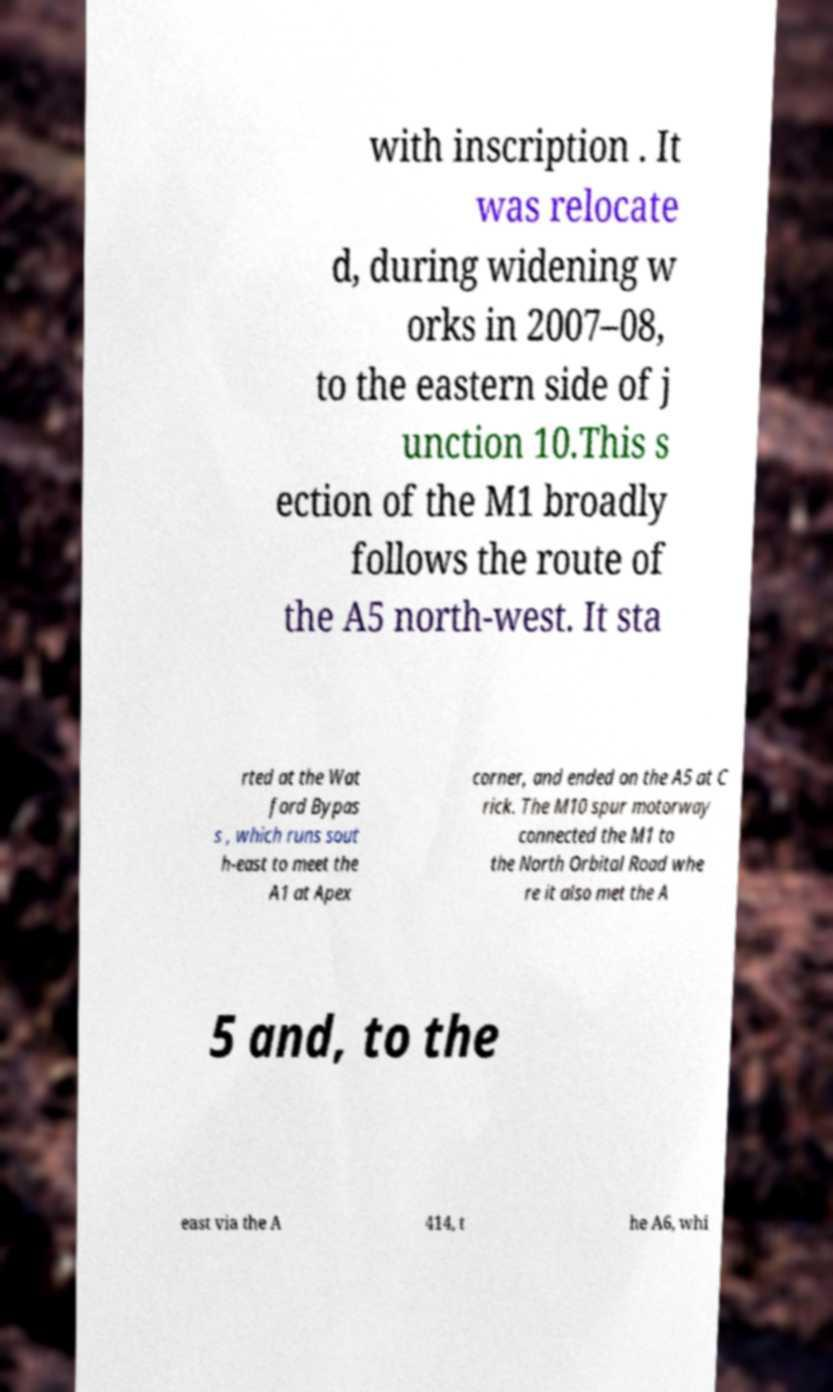Can you read and provide the text displayed in the image?This photo seems to have some interesting text. Can you extract and type it out for me? with inscription . It was relocate d, during widening w orks in 2007–08, to the eastern side of j unction 10.This s ection of the M1 broadly follows the route of the A5 north-west. It sta rted at the Wat ford Bypas s , which runs sout h-east to meet the A1 at Apex corner, and ended on the A5 at C rick. The M10 spur motorway connected the M1 to the North Orbital Road whe re it also met the A 5 and, to the east via the A 414, t he A6, whi 